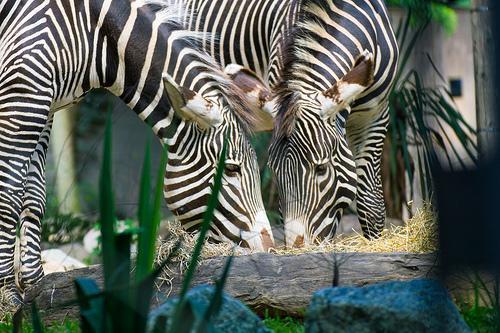How many bears are in the picture?
Give a very brief answer. 0. How many people are riding on elephants?
Give a very brief answer. 0. How many zebras have stripes?
Give a very brief answer. 2. 